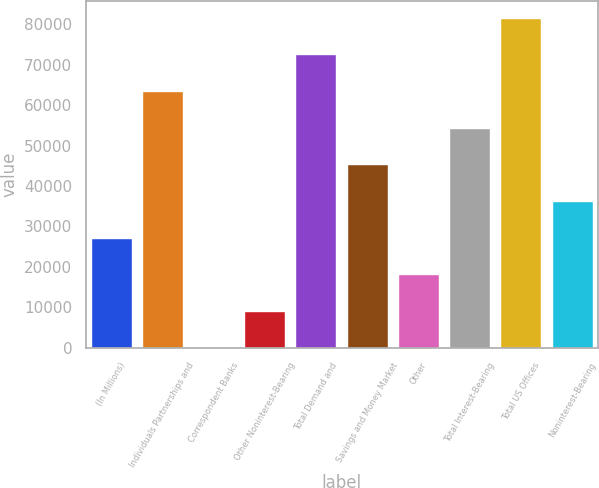Convert chart. <chart><loc_0><loc_0><loc_500><loc_500><bar_chart><fcel>(In Millions)<fcel>Individuals Partnerships and<fcel>Correspondent Banks<fcel>Other Noninterest-Bearing<fcel>Total Demand and<fcel>Savings and Money Market<fcel>Other<fcel>Total Interest-Bearing<fcel>Total US Offices<fcel>Noninterest-Bearing<nl><fcel>27272.3<fcel>63555.5<fcel>59.8<fcel>9130.62<fcel>72626.4<fcel>45413.9<fcel>18201.4<fcel>54484.7<fcel>81697.2<fcel>36343.1<nl></chart> 